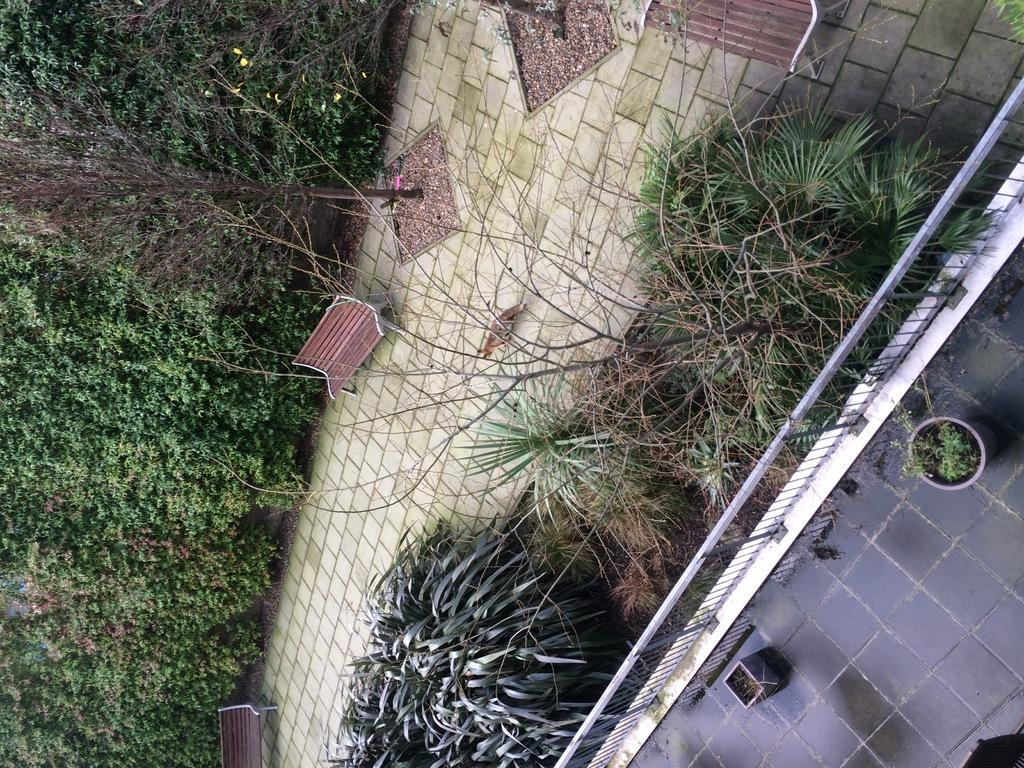What type of vegetation is on the left side of the image? There are trees on the left side of the image. What architectural feature can be seen in the image? There is a railing in the image. What type of vegetation is on the right side of the image? There are plants on the right side of the image. What type of seating is present in the image? There are benches in the image. What type of flooring is visible in the image? There are tiles in the image. What type of fuel is being used by the shoe in the image? There is no shoe present in the image, and therefore no fuel can be associated with it. 